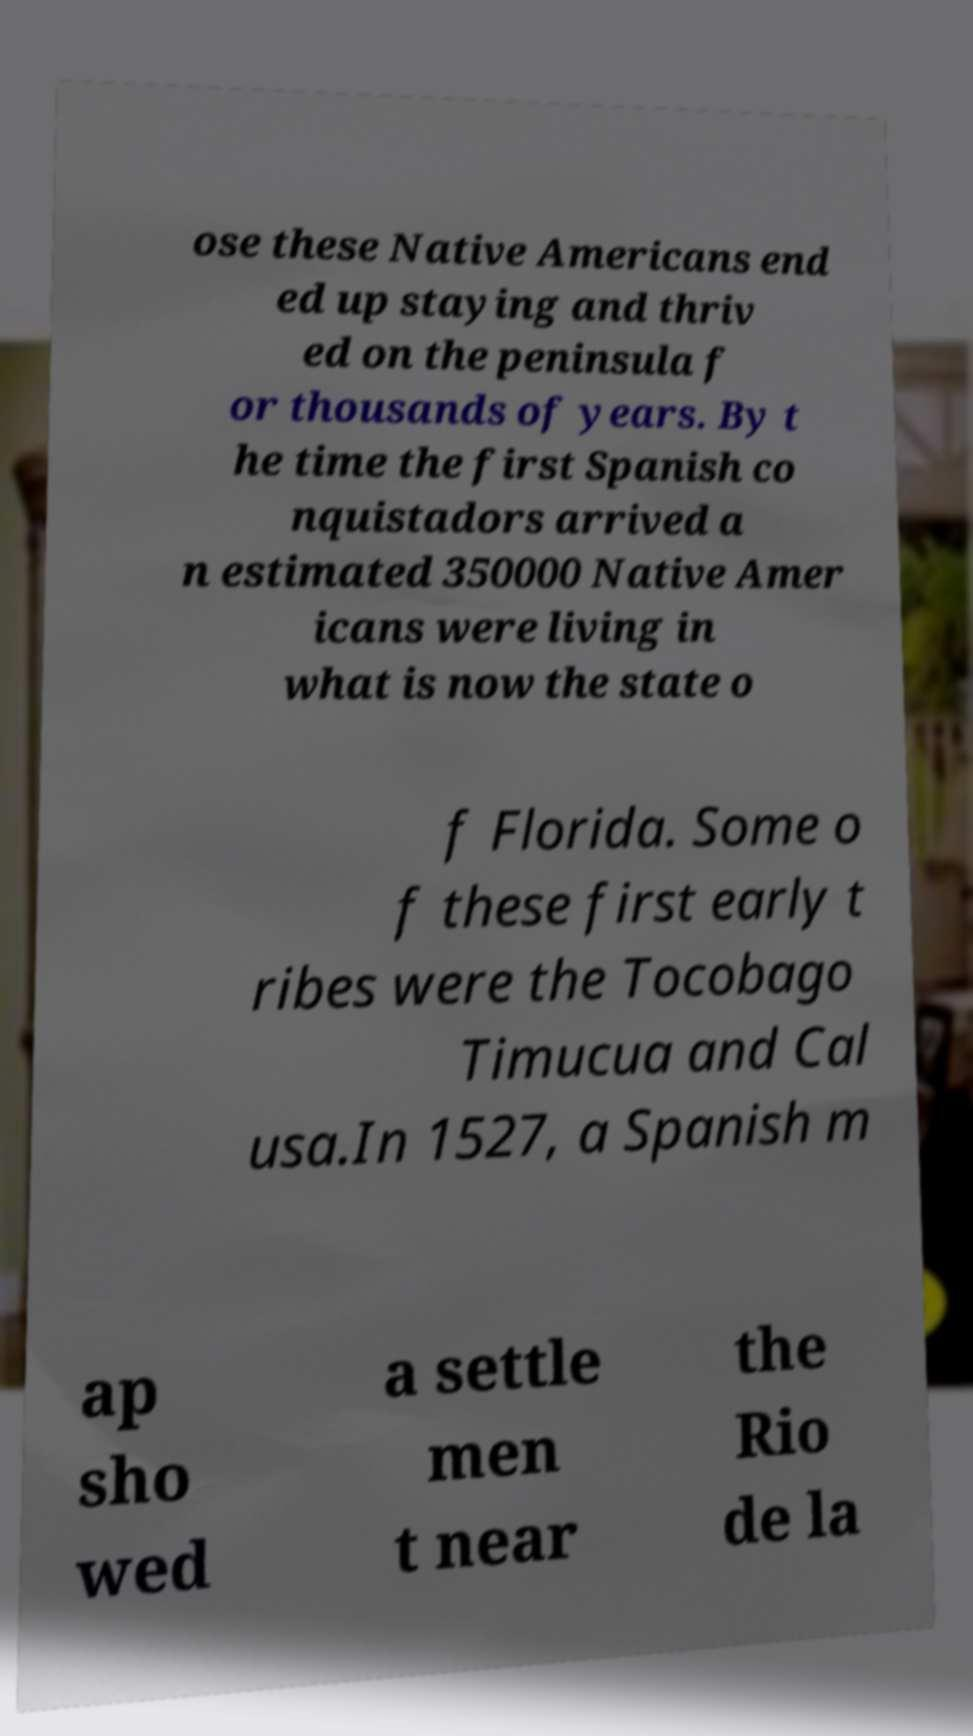I need the written content from this picture converted into text. Can you do that? ose these Native Americans end ed up staying and thriv ed on the peninsula f or thousands of years. By t he time the first Spanish co nquistadors arrived a n estimated 350000 Native Amer icans were living in what is now the state o f Florida. Some o f these first early t ribes were the Tocobago Timucua and Cal usa.In 1527, a Spanish m ap sho wed a settle men t near the Rio de la 